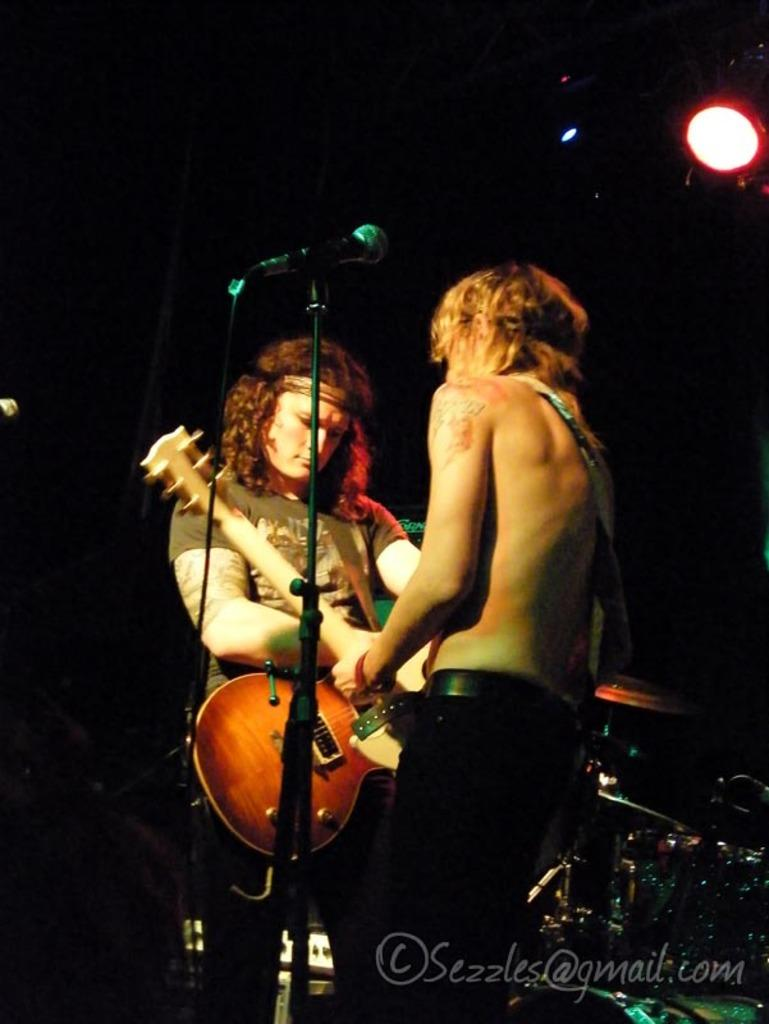Who or what can be seen in the image? There are people in the image. What are the people doing in the image? The people are standing in the image. What objects are the people holding in their hands? The people are holding guitars in their hands. How many geese are visible in the image? There are no geese present in the image. What type of rod is being used by the people in the image? There is no rod visible in the image; the people are holding guitars. 